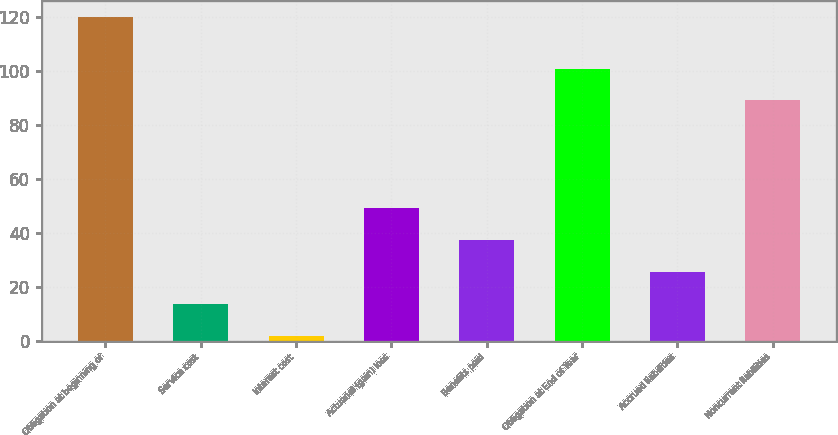Convert chart to OTSL. <chart><loc_0><loc_0><loc_500><loc_500><bar_chart><fcel>Obligation at beginning of<fcel>Service cost<fcel>Interest cost<fcel>Actuarial (gain) loss<fcel>Benefits paid<fcel>Obligation at End of Year<fcel>Accrued liabilities<fcel>Noncurrent liabilities<nl><fcel>119.9<fcel>13.7<fcel>1.9<fcel>49.1<fcel>37.3<fcel>100.8<fcel>25.5<fcel>89<nl></chart> 